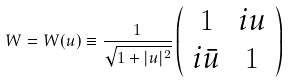Convert formula to latex. <formula><loc_0><loc_0><loc_500><loc_500>W = W ( u ) \equiv \frac { 1 } { \sqrt { 1 + | u | ^ { 2 } } } \left ( \begin{array} { c c } 1 & i u \\ i \bar { u } & 1 \\ \end{array} \right )</formula> 